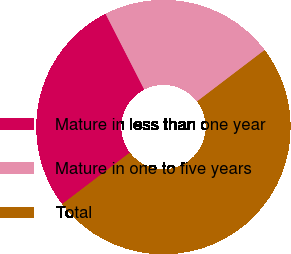Convert chart. <chart><loc_0><loc_0><loc_500><loc_500><pie_chart><fcel>Mature in less than one year<fcel>Mature in one to five years<fcel>Total<nl><fcel>27.83%<fcel>22.17%<fcel>50.0%<nl></chart> 